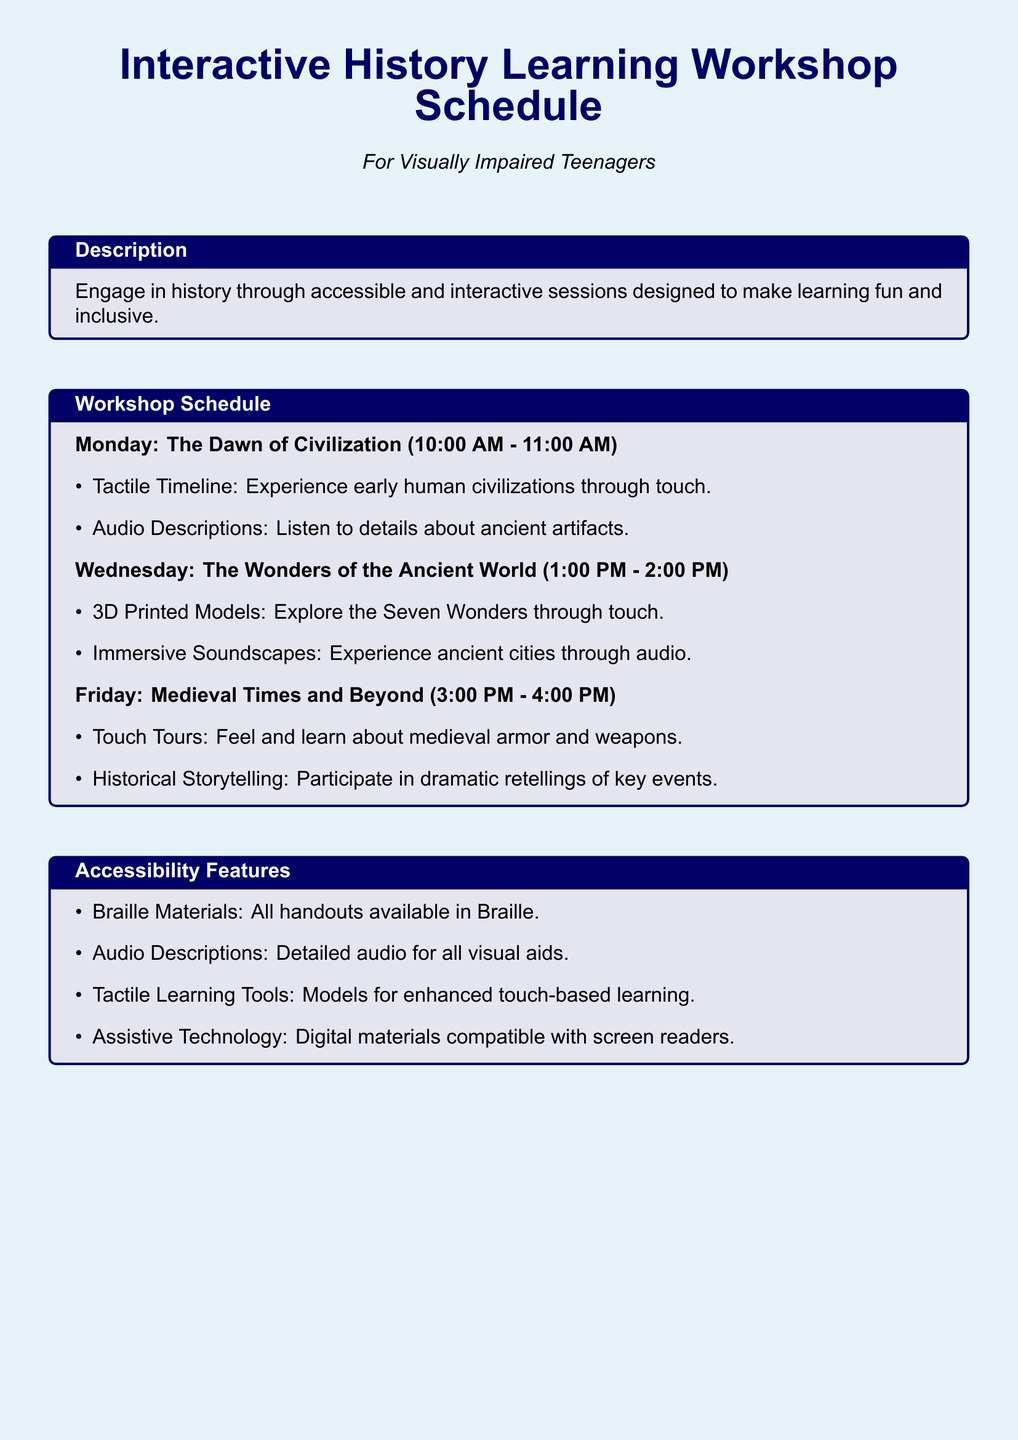What day is the workshop on The Dawn of Civilization? The schedule lists events on specific days, and The Dawn of Civilization is on Monday.
Answer: Monday What time does the workshop on Medieval Times and Beyond start? The schedule provides start times for each workshop, and Medieval Times starts at 3:00 PM.
Answer: 3:00 PM What materials are provided in Braille? The document states that all handouts are available in Braille.
Answer: Handouts Which workshop includes tactile learning tools? The Accessibility Features section mentions tactile learning tools, which are part of the workshops.
Answer: All workshops What is the focus of the Wednesday workshop? The document specifies that Wednesday's workshop discusses The Wonders of the Ancient World.
Answer: The Wonders of the Ancient World What type of learning does the Touch Tours activity focus on? The Touch Tours activity is designed to be tactile, allowing participants to feel historical objects.
Answer: Touch-based learning What is the duration of each workshop session? Each workshop session mentioned in the schedule lasts for one hour.
Answer: One hour What feature enhances audio learning for visually impaired participants? The document notes the use of audio descriptions for visual aids.
Answer: Audio Descriptions What is the main purpose of the workshop sessions? The schedule aims to engage participants in history through interactive and accessible methods.
Answer: Fun and inclusive 